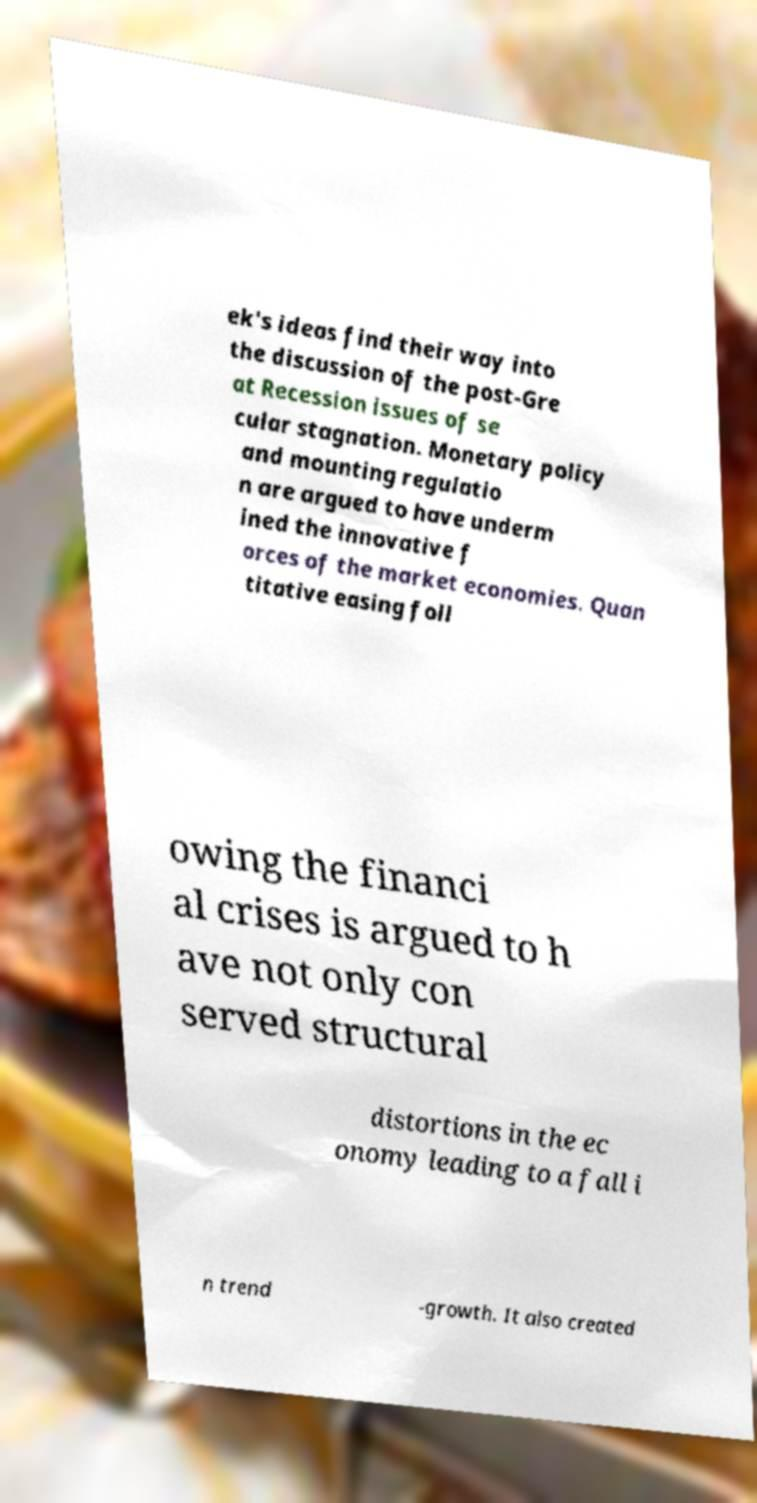What messages or text are displayed in this image? I need them in a readable, typed format. ek's ideas find their way into the discussion of the post-Gre at Recession issues of se cular stagnation. Monetary policy and mounting regulatio n are argued to have underm ined the innovative f orces of the market economies. Quan titative easing foll owing the financi al crises is argued to h ave not only con served structural distortions in the ec onomy leading to a fall i n trend -growth. It also created 